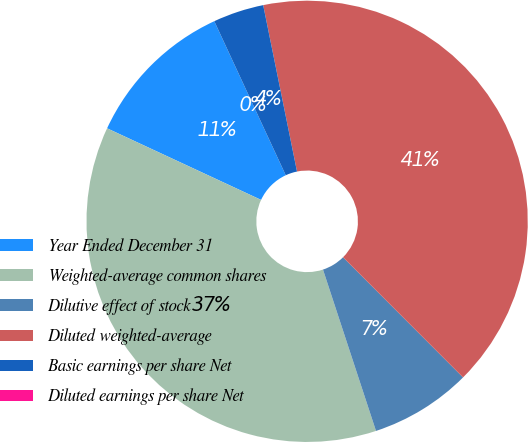Convert chart. <chart><loc_0><loc_0><loc_500><loc_500><pie_chart><fcel>Year Ended December 31<fcel>Weighted-average common shares<fcel>Dilutive effect of stock<fcel>Diluted weighted-average<fcel>Basic earnings per share Net<fcel>Diluted earnings per share Net<nl><fcel>11.16%<fcel>36.98%<fcel>7.44%<fcel>40.7%<fcel>3.72%<fcel>0.0%<nl></chart> 